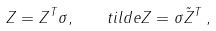Convert formula to latex. <formula><loc_0><loc_0><loc_500><loc_500>Z = Z ^ { T } \sigma , \quad t i l d e { Z } = \sigma \tilde { Z } ^ { T } \, ,</formula> 